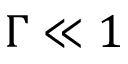<formula> <loc_0><loc_0><loc_500><loc_500>\Gamma \ll 1</formula> 